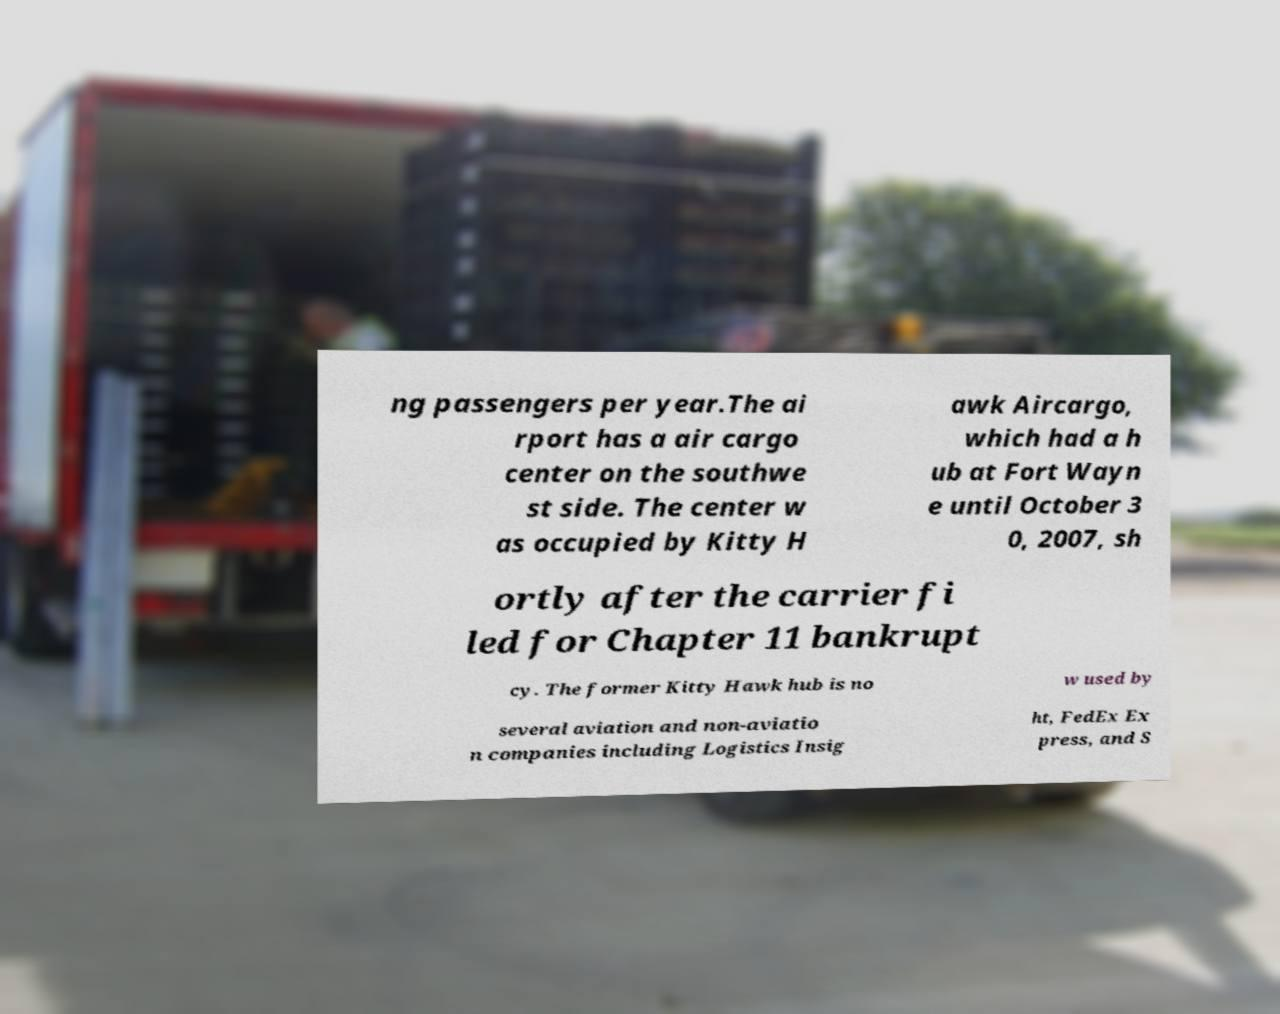There's text embedded in this image that I need extracted. Can you transcribe it verbatim? ng passengers per year.The ai rport has a air cargo center on the southwe st side. The center w as occupied by Kitty H awk Aircargo, which had a h ub at Fort Wayn e until October 3 0, 2007, sh ortly after the carrier fi led for Chapter 11 bankrupt cy. The former Kitty Hawk hub is no w used by several aviation and non-aviatio n companies including Logistics Insig ht, FedEx Ex press, and S 